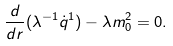<formula> <loc_0><loc_0><loc_500><loc_500>\frac { d } { d r } ( \lambda ^ { - 1 } \dot { q } ^ { 1 } ) - \lambda m _ { 0 } ^ { 2 } = 0 .</formula> 